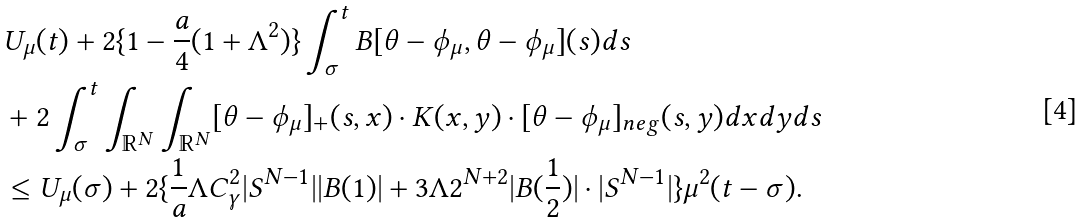<formula> <loc_0><loc_0><loc_500><loc_500>& U _ { \mu } ( t ) + 2 \{ 1 - \frac { a } { 4 } ( 1 + \Lambda ^ { 2 } ) \} \int _ { \sigma } ^ { t } B [ \theta - \phi _ { \mu } , \theta - \phi _ { \mu } ] ( s ) d s \\ & + 2 \int _ { \sigma } ^ { t } \int _ { \mathbb { R } ^ { N } } \int _ { \mathbb { R } ^ { N } } [ \theta - \phi _ { \mu } ] _ { + } ( s , x ) \cdot K ( x , y ) \cdot [ \theta - \phi _ { \mu } ] _ { n e g } ( s , y ) d x d y d s \\ & \leq U _ { \mu } ( \sigma ) + 2 \{ \frac { 1 } { a } \Lambda C _ { \gamma } ^ { 2 } | S ^ { N - 1 } | | B ( 1 ) | + 3 \Lambda 2 ^ { N + 2 } | B ( \frac { 1 } { 2 } ) | \cdot | S ^ { N - 1 } | \} \mu ^ { 2 } ( t - \sigma ) .</formula> 